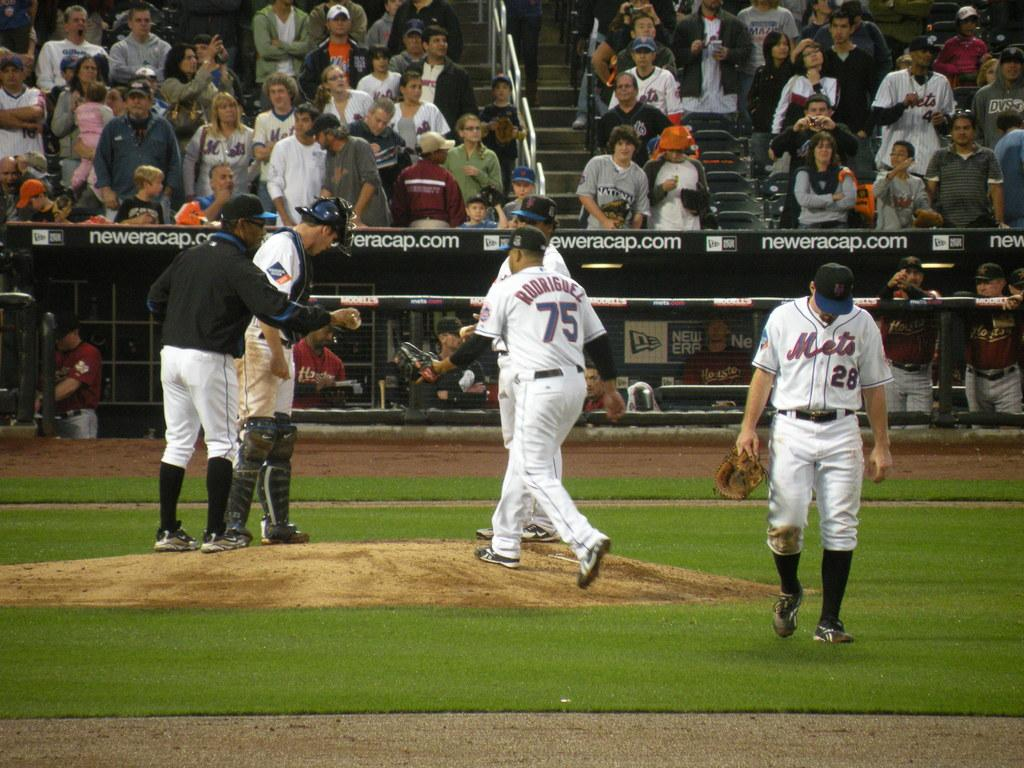<image>
Relay a brief, clear account of the picture shown. A mets game on the pitchers mount with Rodriguez number 75 walking. 